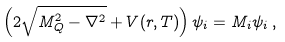Convert formula to latex. <formula><loc_0><loc_0><loc_500><loc_500>\left ( 2 \sqrt { M _ { Q } ^ { 2 } - \nabla ^ { 2 } } + V ( r , T ) \right ) \psi _ { i } = M _ { i } \psi _ { i } \, ,</formula> 